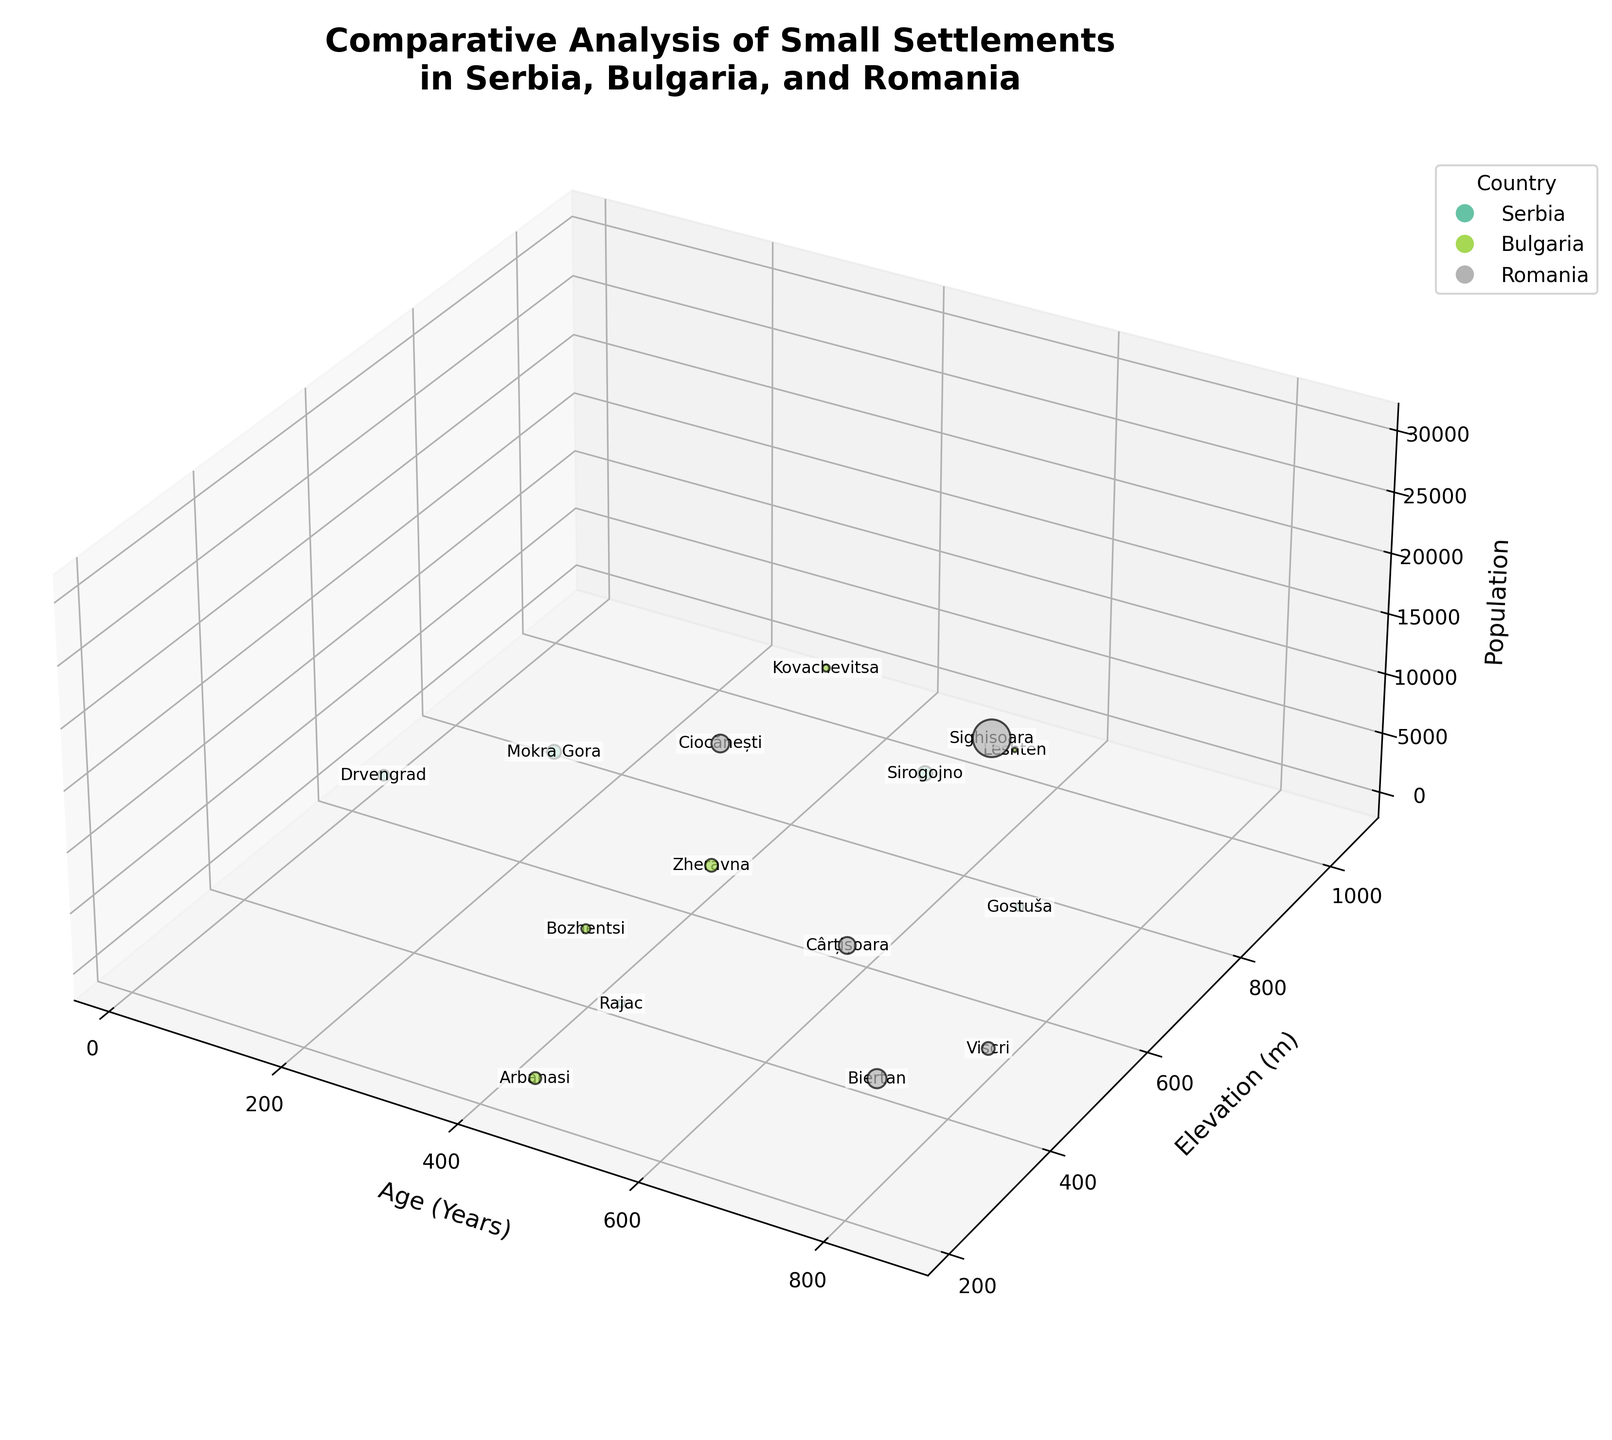How many settlements are shown for each country? Serbia has 5 settlements, Bulgaria has 5 settlements, and Romania has 5 settlements. This can be counted from the data points for each country in the scatter plot.
Answer: Serbia: 5, Bulgaria: 5, Romania: 5 Which country has the oldest settlement, and what is its age? The figure shows the Age (Years) on the x-axis. The oldest settlement is in Romania, and its age is 850 years.
Answer: Romania, 850 years What is the name of the Serbian settlement with the highest elevation? The y-axis represents Elevation (m). Among Serbian settlements, Sirogojno has the highest elevation of 900 meters.
Answer: Sirogojno Compare the populations of the oldest settlements in each country. The oldest settlements for each country are: Serbia: Gostuša (700 years), Bulgaria: Leshten (550 years), Romania: Sighișoara (850 years). Their populations are 70, 5, and 30000 respectively.
Answer: Serbia: 70, Bulgaria: 5, Romania: 30000 Which settlement has the largest population? The size of the bubbles represents the population. Sighișoara in Romania has the largest population with 30000 inhabitants.
Answer: Sighișoara What is the average elevation of settlements in Serbia? The elevations of Serbian settlements are 900, 730, 380, 750, 630. Calculating the average: (900 + 730 + 380 + 750 + 630) / 5 = 2780 / 5 = 556 m
Answer: 556 m How does the elevation of Leshten compare to the elevation of Rajac? Leshten's elevation is 1000 meters while Rajac's elevation is 380 meters. Leshten is higher.
Answer: Leshten is higher What is the total population of settlements in Bulgaria? The populations are 40, 5, 400, 100, and 300. The total is 40 + 5 + 400 + 100 + 300 = 845.
Answer: 845 What is the youngest settlement and how does its population compare to the oldest settlement in Serbia? The youngest settlement is Drvengrad in Serbia with an age of 20 years and a population of 200. The oldest settlement in Serbia is Gostuša with 70 people. So, Drvengrad's population is larger.
Answer: Drvengrad has a larger population Which settlement has the highest elevation across all three countries, and what is its population? The highest elevation is Kovachevitsa in Bulgaria at 1050 meters, with a population of 40.
Answer: Kovachevitsa, 40 